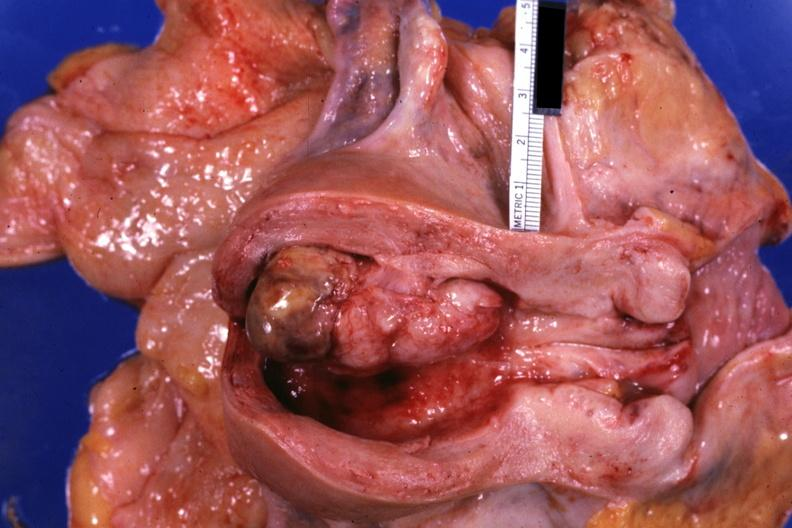what is present?
Answer the question using a single word or phrase. Female reproductive 